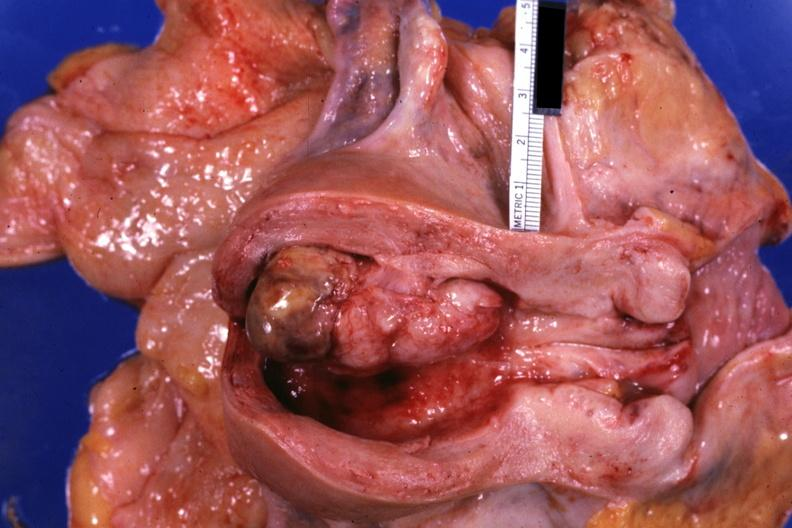what is present?
Answer the question using a single word or phrase. Female reproductive 